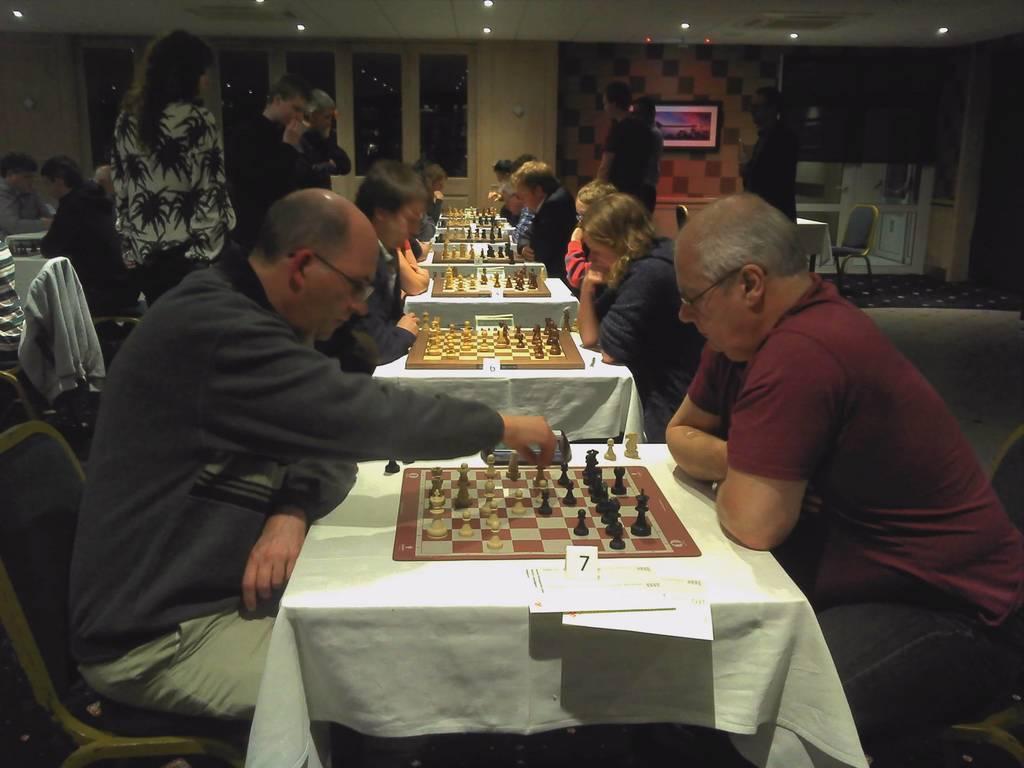Could you give a brief overview of what you see in this image? This picture shows a serial tables and people sitting in front of the table and playing chess and few people standing at the back 